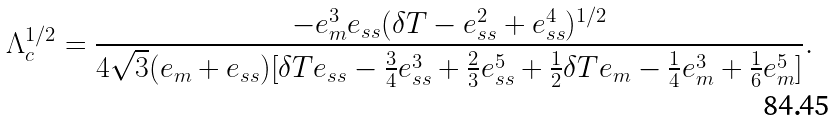<formula> <loc_0><loc_0><loc_500><loc_500>\Lambda _ { c } ^ { 1 / 2 } = \frac { - e _ { m } ^ { 3 } e _ { s s } ( \delta T - e _ { s s } ^ { 2 } + e _ { s s } ^ { 4 } ) ^ { 1 / 2 } } { 4 \sqrt { 3 } ( e _ { m } + e _ { s s } ) [ \delta T e _ { s s } - \frac { 3 } { 4 } e _ { s s } ^ { 3 } + \frac { 2 } { 3 } e _ { s s } ^ { 5 } + \frac { 1 } { 2 } \delta T e _ { m } - \frac { 1 } { 4 } e _ { m } ^ { 3 } + \frac { 1 } { 6 } e _ { m } ^ { 5 } ] } .</formula> 